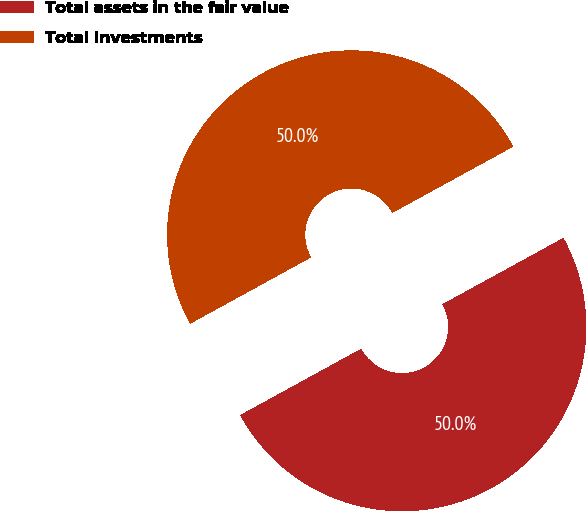Convert chart to OTSL. <chart><loc_0><loc_0><loc_500><loc_500><pie_chart><fcel>Total assets in the fair value<fcel>Total Investments<nl><fcel>49.99%<fcel>50.01%<nl></chart> 